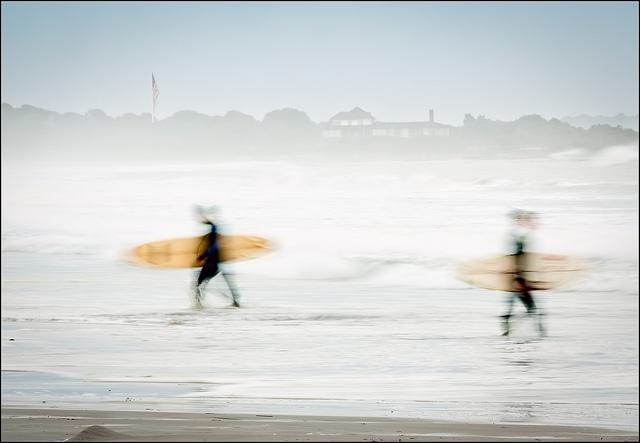How many blurry figures are passing the ocean with a surfboard in their hands?

Choices:
A) three
B) four
C) two
D) one two 